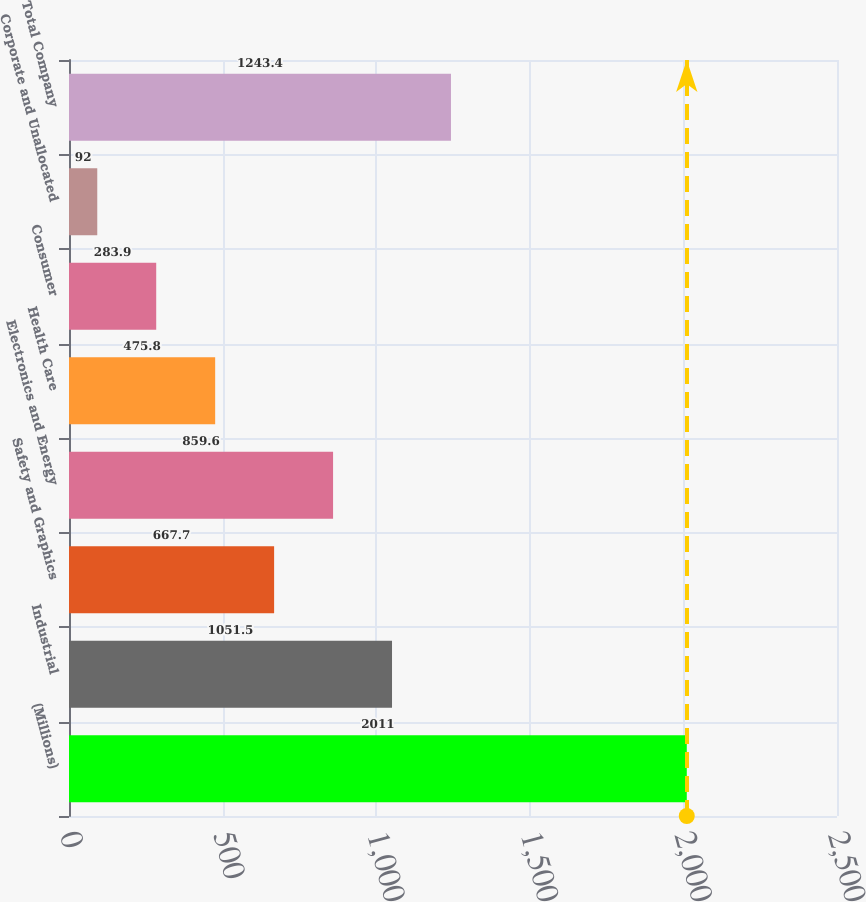Convert chart to OTSL. <chart><loc_0><loc_0><loc_500><loc_500><bar_chart><fcel>(Millions)<fcel>Industrial<fcel>Safety and Graphics<fcel>Electronics and Energy<fcel>Health Care<fcel>Consumer<fcel>Corporate and Unallocated<fcel>Total Company<nl><fcel>2011<fcel>1051.5<fcel>667.7<fcel>859.6<fcel>475.8<fcel>283.9<fcel>92<fcel>1243.4<nl></chart> 